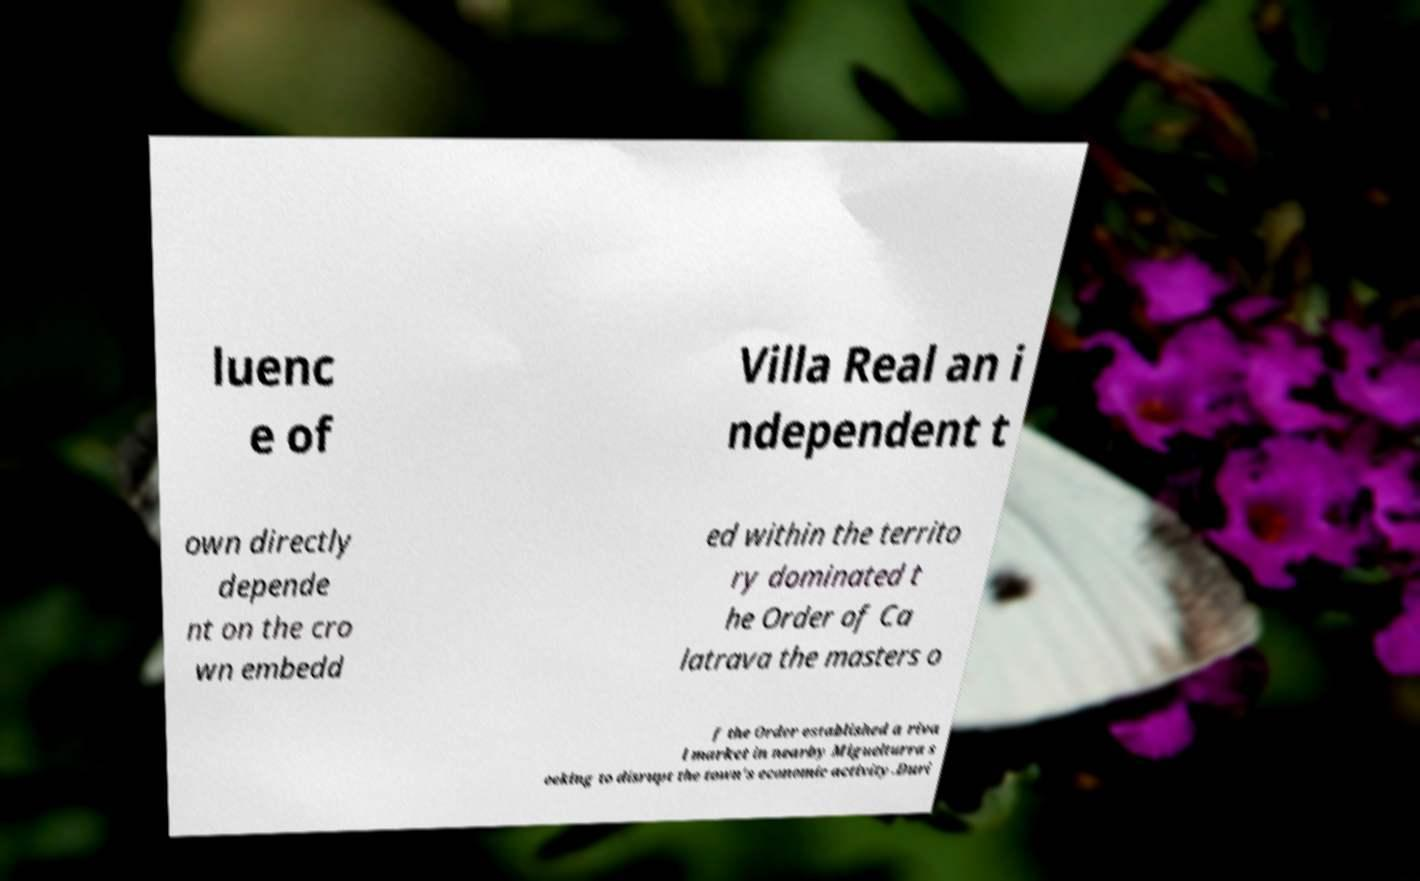Can you read and provide the text displayed in the image?This photo seems to have some interesting text. Can you extract and type it out for me? luenc e of Villa Real an i ndependent t own directly depende nt on the cro wn embedd ed within the territo ry dominated t he Order of Ca latrava the masters o f the Order established a riva l market in nearby Miguelturra s eeking to disrupt the town's economic activity.Duri 